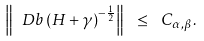Convert formula to latex. <formula><loc_0><loc_0><loc_500><loc_500>\left \| { \ D b } \left ( H + \gamma \right ) ^ { - \frac { 1 } { 2 } } \right \| \ \leq \ C _ { \alpha , \beta } .</formula> 